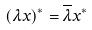<formula> <loc_0><loc_0><loc_500><loc_500>( \lambda x ) ^ { * } = \overline { \lambda } x ^ { * }</formula> 